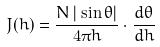<formula> <loc_0><loc_0><loc_500><loc_500>J ( h ) = \frac { N \, | \sin \theta | } { 4 \pi h } \cdot \frac { d \theta } { d h }</formula> 